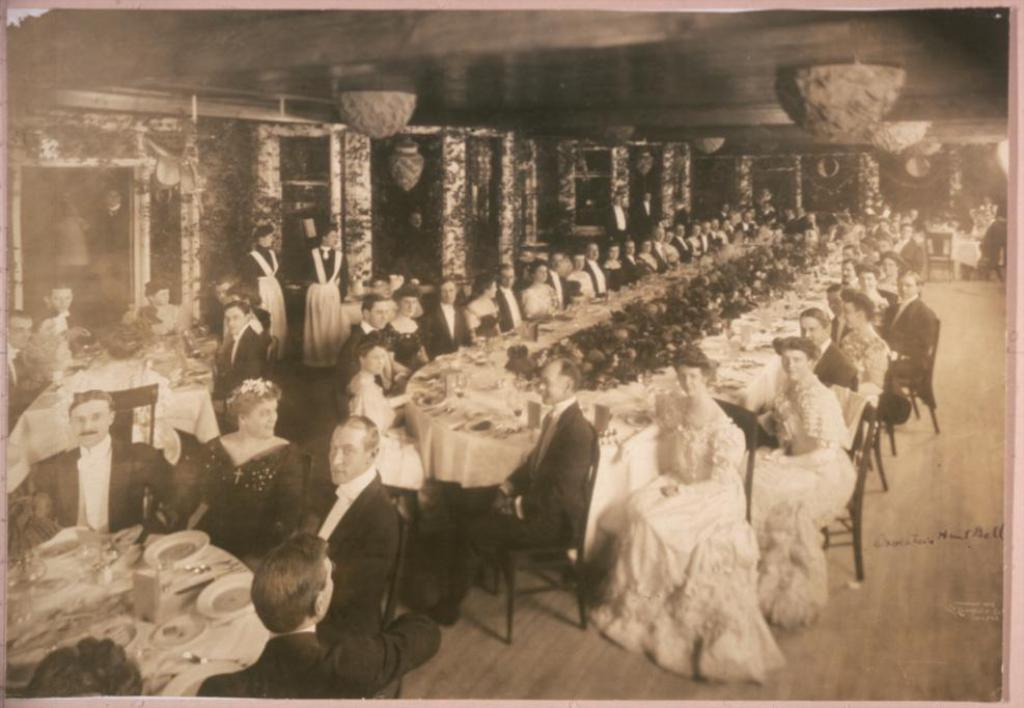What type of furniture is in the image? There is a long dining table in the image. What are the people in the image doing? A group of people are sitting at the long dining table. Are there any other tables in the image besides the long dining table? Yes, there are other tables in the image. What are the people at these other tables doing? Some people are sitting in groups at these other tables. Can you tell me how many ants are crawling on the table in the image? There is no mention of ants in the image, so it is not possible to determine how many ants might be present. What type of fuel is being used by the passenger in the image? There is no passenger or mention of fuel in the image. 